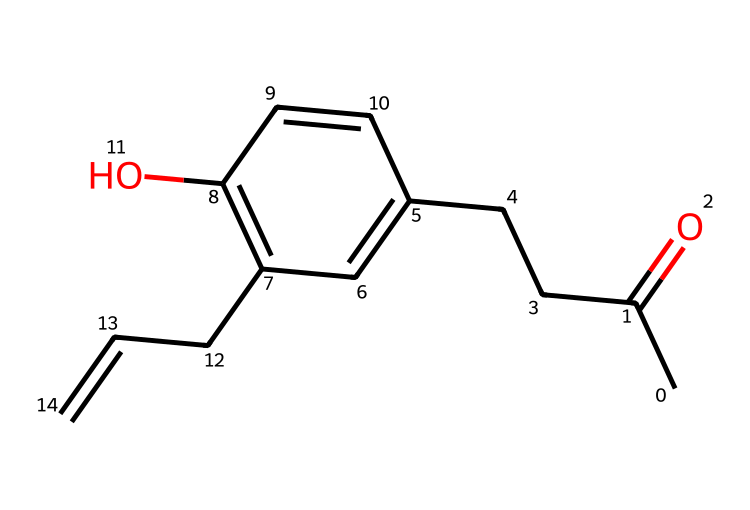What is the molecular formula of raspberry ketone? To find the molecular formula, we count the number of each type of atom in the SMILES representation. In the provided SMILES, there are 10 carbon (C) atoms, 12 hydrogen (H) atoms, and 2 oxygen (O) atoms. Therefore, the molecular formula is C10H12O2.
Answer: C10H12O2 How many double bonds are present in the structure? By examining the SMILES, we identify the presence of double bonds, specifically the "C=C" and "C=O" parts. Counting these, there are three double bonds in total.
Answer: 3 What functional group does raspberry ketone contain? Observing the SMILES structure, we identify the carbonyl group (C=O), which is characteristic of ketones. Thus, the presence of this functional group indicates that raspberry ketone is a ketone.
Answer: ketone What is the relationship between raspberry ketone and its aroma properties? The presence of the aromatic rings (indicated by the "C1=CC" and "C=C" parts) in the molecule suggests that raspberry ketone is likely to have a pleasant fruity aroma, typical of many natural compounds used in aromatherapy.
Answer: pleasant aroma How many cyclic components are present in the structure? The cyclic components can be identified from the SMILES notation where we notice the "C1" indicating the start of a ring. After analyzing it, we find it consists of one cyclic benzene ring.
Answer: 1 Does raspberry ketone have any hydroxyl groups? In the SMILES representation, the presence of "C(C=C1)O" indicates that one of the carbon atoms is bonded to a hydroxyl group (-OH). Hence, there is one hydroxyl group present in the structure.
Answer: 1 